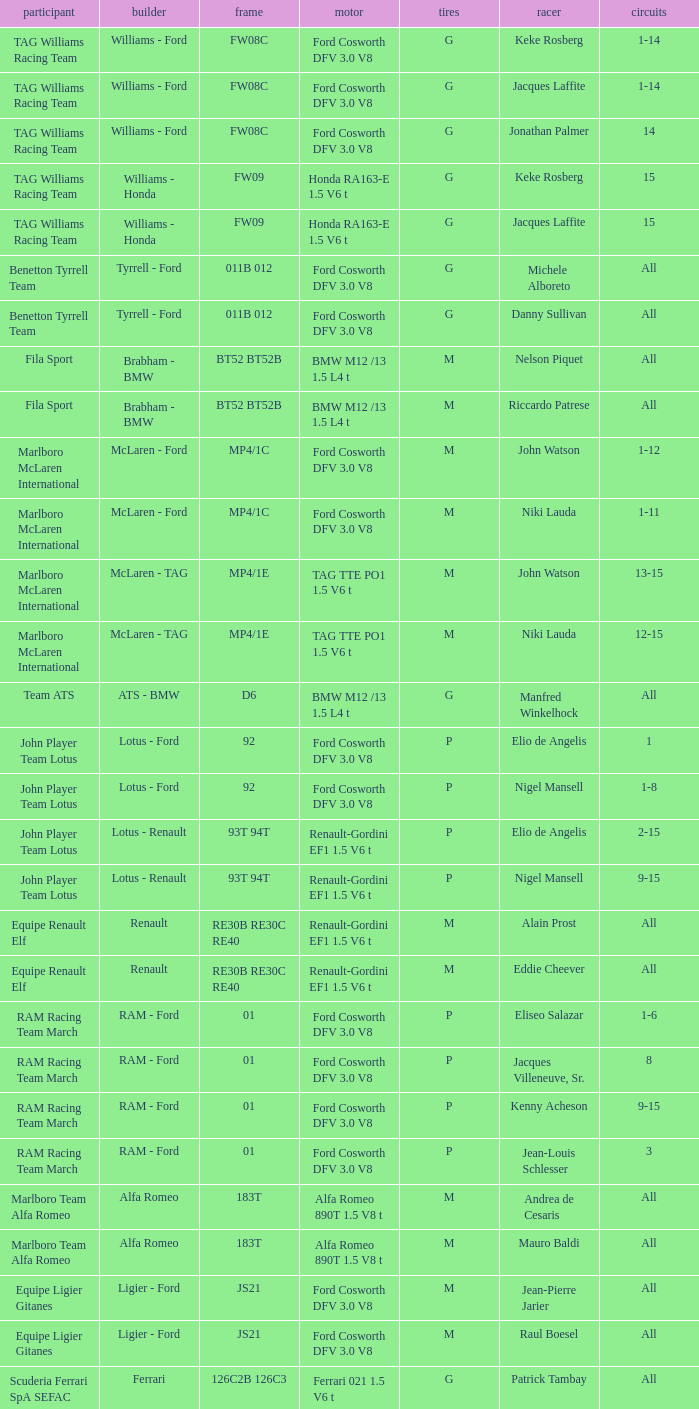Who is the Constructor for driver Piercarlo Ghinzani and a Ford cosworth dfv 3.0 v8 engine? Osella - Ford. 